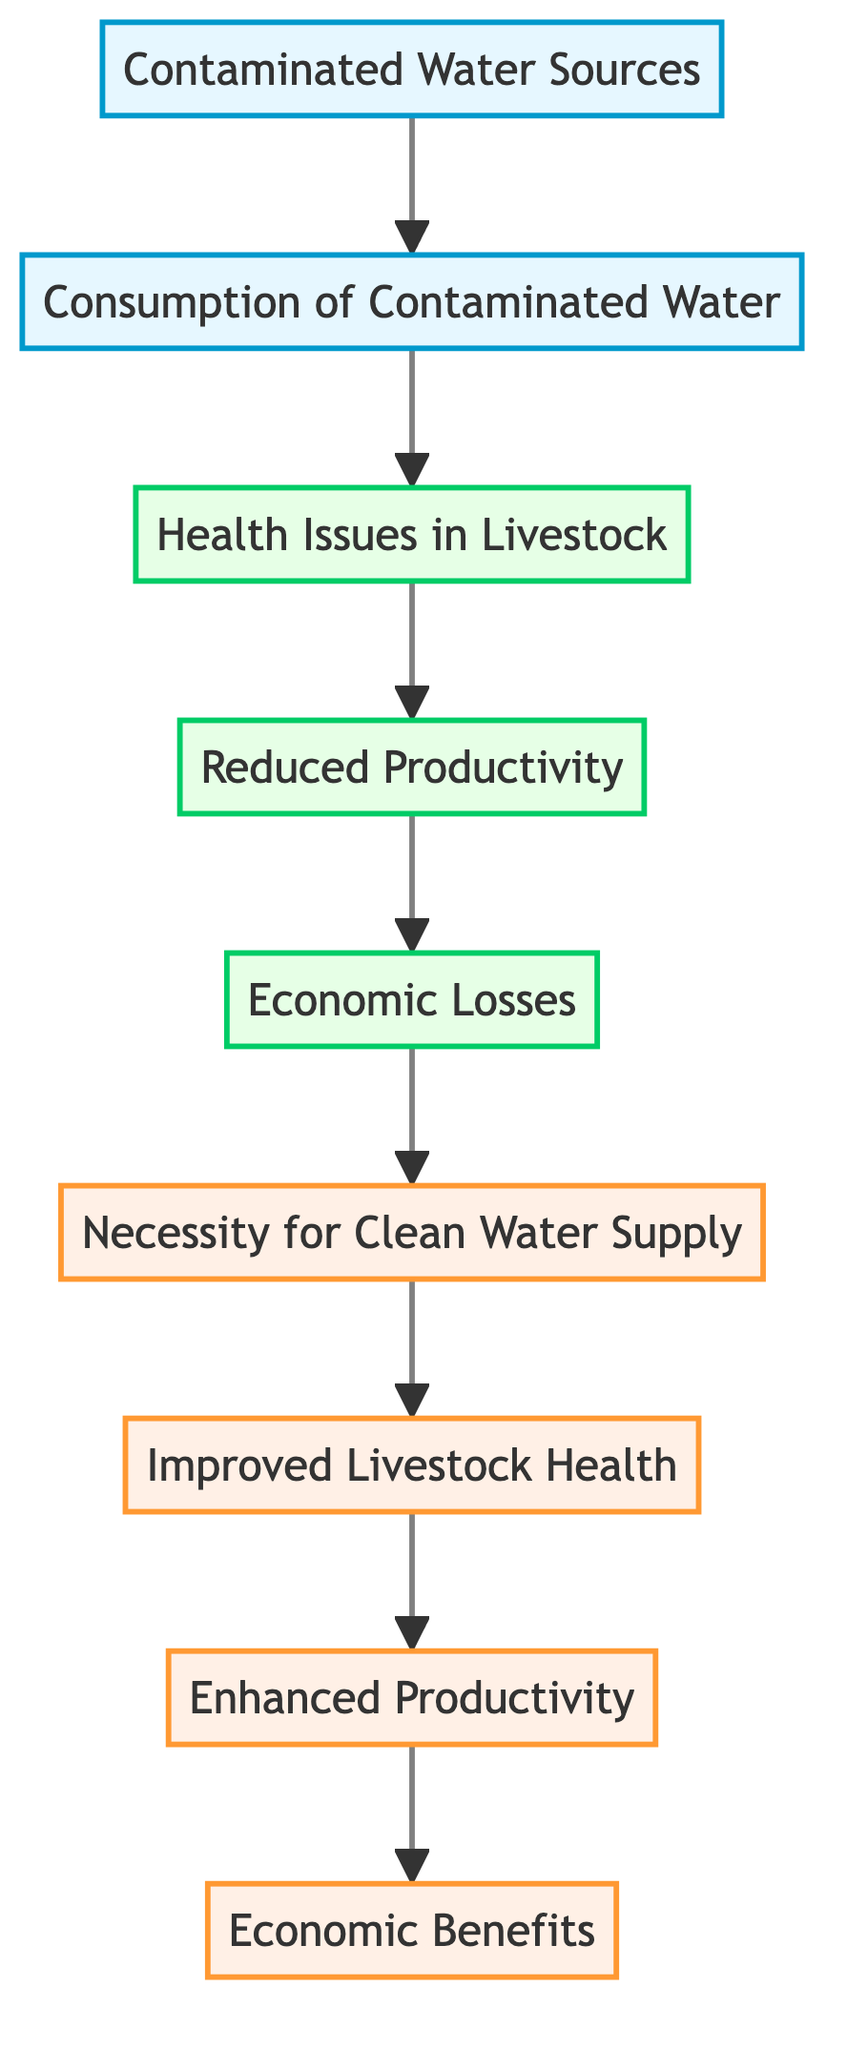What is the first node in the diagram? The first node in the diagram is labeled "Contaminated Water Sources", which is at the bottom of the flow chart.
Answer: Contaminated Water Sources How many nodes are in the diagram? There are 9 nodes in total as each title from "Contaminated Water Sources" to "Economic Benefits" is represented as one distinct node.
Answer: 9 What is the last node in the diagram? The last node is labeled "Economic Benefits", which is the topmost node of the flow chart and represents the desired outcome.
Answer: Economic Benefits What is the relationship between "Health Issues in Livestock" and "Reduced Productivity"? "Health Issues in Livestock" directly leads to "Reduced Productivity", indicating that health issues negatively affect livestock productivity levels.
Answer: Direct relationship Which node indicates the necessity of maintaining water quality? The node "Necessity for Clean Water Supply" highlights the importance of ensuring clean water sources to prevent health issues in livestock.
Answer: Necessity for Clean Water Supply What improvements are associated with “Improved Livestock Health”? "Improved Livestock Health" leads to several positive outcomes, including enhanced productivity and reduced disease incidence, showcasing the benefits of healthy livestock.
Answer: Enhanced Productivity What happens if livestock consume contaminated water? If livestock consume contaminated water, it leads to "Health Issues in Livestock", which cascade into further negative effects, culminating in economic losses.
Answer: Health Issues in Livestock How are “Economic Losses” related to “Reduced Productivity”? "Economic Losses" are a result of decreased productivity stemming from health issues, indicating a clear cause-and-effect relationship between the two nodes.
Answer: Cause-and-effect relationship What do the top three nodes in the diagram represent? The top three nodes represent positive outcomes: "Necessity for Clean Water Supply", "Improved Livestock Health", and "Enhanced Productivity", demonstrating the upward benefits of water quality.
Answer: Positive outcomes 